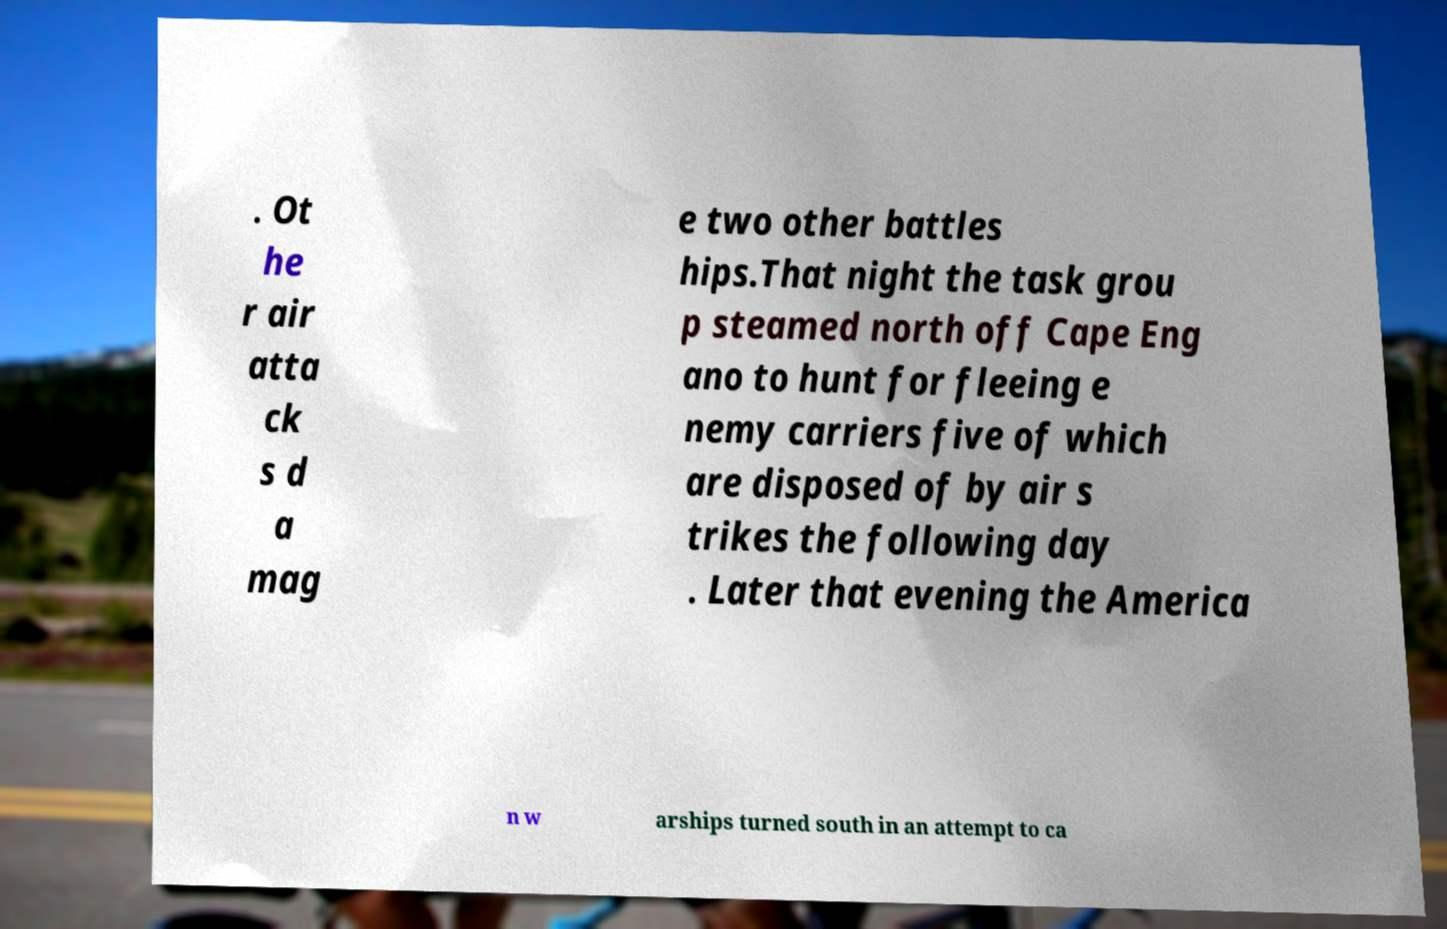Can you read and provide the text displayed in the image?This photo seems to have some interesting text. Can you extract and type it out for me? . Ot he r air atta ck s d a mag e two other battles hips.That night the task grou p steamed north off Cape Eng ano to hunt for fleeing e nemy carriers five of which are disposed of by air s trikes the following day . Later that evening the America n w arships turned south in an attempt to ca 